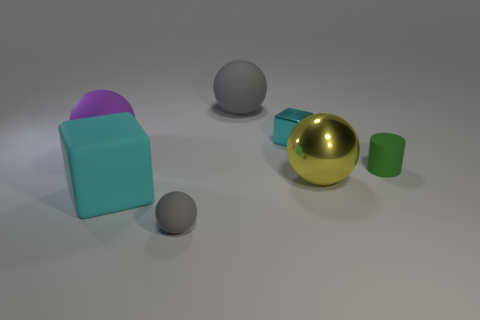Is the purple sphere made of the same material as the cube that is on the right side of the small gray matte sphere?
Your answer should be very brief. No. The purple rubber thing that is the same shape as the yellow shiny object is what size?
Provide a succinct answer. Large. Are there an equal number of tiny blocks left of the purple sphere and balls behind the large matte cube?
Provide a short and direct response. No. What number of other things are there of the same material as the tiny cylinder
Offer a terse response. 4. Are there an equal number of big objects in front of the tiny matte ball and small yellow metal cylinders?
Your response must be concise. Yes. Does the yellow metal ball have the same size as the gray matte sphere that is right of the small gray sphere?
Ensure brevity in your answer.  Yes. The green thing that is to the right of the tiny rubber ball has what shape?
Give a very brief answer. Cylinder. Is there any other thing that is the same shape as the tiny gray matte thing?
Provide a short and direct response. Yes. Are any things visible?
Offer a terse response. Yes. Is the size of the cube behind the purple thing the same as the gray rubber sphere in front of the green cylinder?
Offer a terse response. Yes. 